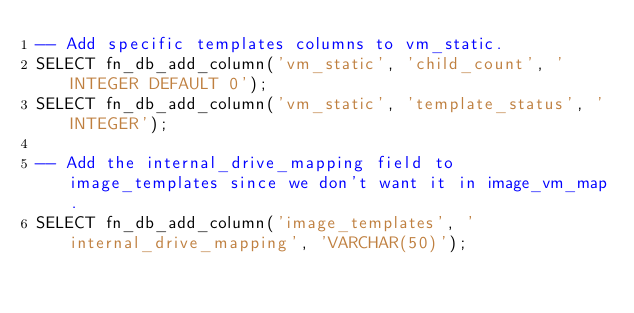Convert code to text. <code><loc_0><loc_0><loc_500><loc_500><_SQL_>-- Add specific templates columns to vm_static.
SELECT fn_db_add_column('vm_static', 'child_count', 'INTEGER DEFAULT 0');
SELECT fn_db_add_column('vm_static', 'template_status', 'INTEGER');

-- Add the internal_drive_mapping field to image_templates since we don't want it in image_vm_map.
SELECT fn_db_add_column('image_templates', 'internal_drive_mapping', 'VARCHAR(50)');

</code> 